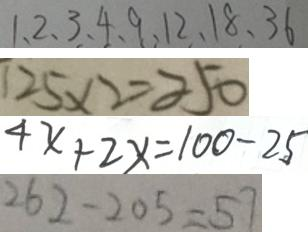<formula> <loc_0><loc_0><loc_500><loc_500>1 、 2 、 3 、 4 、 9 、 1 2 、 1 8 、 3 6 
 1 2 5 \times 2 = 2 5 0 
 4 x + 2 x = 1 0 0 - 2 5 
 2 6 2 - 2 0 5 = 5 7</formula> 